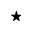<formula> <loc_0><loc_0><loc_500><loc_500>^ { * }</formula> 